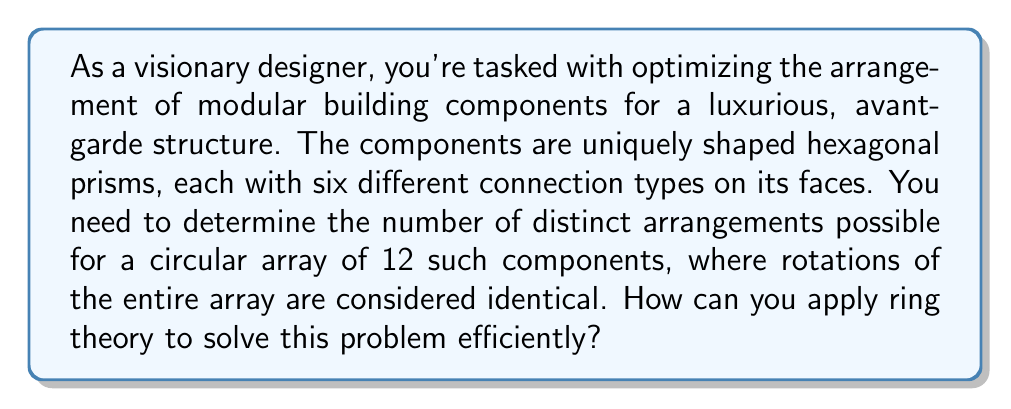Can you answer this question? To solve this problem using ring theory, we can follow these steps:

1) First, we need to recognize that the arrangement of the components forms a cyclic group of order 12. This is because rotations of the entire array are considered identical, which is a key property of cyclic groups.

2) Each hexagonal prism has 6 different connection types, one on each face. This means for each component, we have 6 choices for its orientation. Therefore, for 12 components, we initially have $6^{12}$ possible arrangements.

3) However, we need to account for the rotational symmetry. In ring theory, we can use the Orbit-Stabilizer theorem to handle this. The theorem states:

   $$ |G| = |Orb(x)| \cdot |Stab(x)| $$

   Where $G$ is our group of all possible arrangements, $Orb(x)$ is the orbit of an arrangement $x$ (i.e., all distinct rotations of $x$), and $Stab(x)$ is the stabilizer of $x$ (i.e., rotations that leave $x$ unchanged).

4) In our case, $|G| = 6^{12}$, and $|Orb(x)| = 12$ for most arrangements (as rotating by any amount gives a new arrangement).

5) Applying the theorem:

   $$ 6^{12} = 12 \cdot |Stab(x)| $$

   $$ |Stab(x)| = \frac{6^{12}}{12} = 6^{11} $$

6) The number of distinct arrangements is equal to $|G| / |Stab(x)|$, which gives us:

   $$ \text{Number of distinct arrangements} = \frac{6^{12}}{6^{11}} = 6 $$

This result might seem surprisingly small, but it's correct due to the high degree of symmetry in the problem.
Answer: The number of distinct arrangements is 6. 